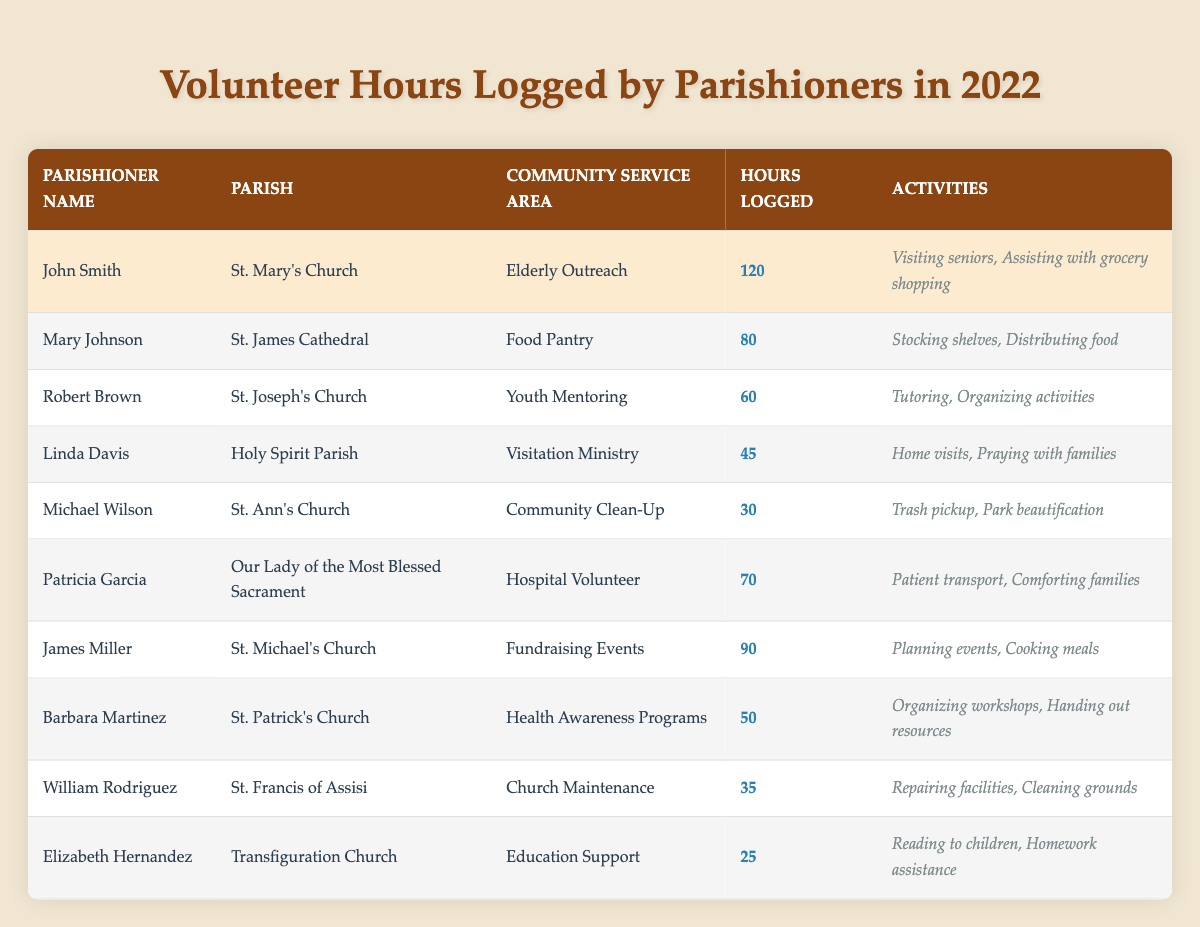What is the total number of volunteer hours logged by all parishioners? To find the total, add the hours logged by each parishioner: 120 + 80 + 60 + 45 + 30 + 70 + 90 + 50 + 35 + 25 = 600.
Answer: 600 Who logged the most volunteer hours in 2022? By comparing the hours logged by each parishioner, John Smith logged the highest at 120 hours.
Answer: John Smith What community service area did Patricia Garcia serve in? The table indicates that Patricia Garcia served in the Hospital Volunteer community service area.
Answer: Hospital Volunteer How many hours did Robert Brown log compared to Linda Davis? Robert Brown logged 60 hours while Linda Davis logged 45 hours. The difference is 60 - 45 = 15.
Answer: 15 hours What activity was done by volunteers in both the Elderly Outreach and Hospital Volunteer community service areas? Both John Smith (Elderly Outreach) and Patricia Garcia (Hospital Volunteer) engaged in activities that focused on assisting and comforting seniors.
Answer: Visiting seniors, comforting families Is the number of hours logged by James Miller more than that of Elizabeth Hernandez? James Miller logged 90 hours, while Elizabeth Hernandez logged 25 hours. Since 90 > 25, the statement is true.
Answer: Yes What is the average number of hours logged by the parishioners? To calculate the average, sum the hours (600) and divide by the number of parishioners (10): 600 / 10 = 60.
Answer: 60 Did any parishioner log fewer than 30 hours? By reviewing the table, the lowest logged hours is 25 by Elizabeth Hernandez, so yes, there is a parishioner who logged fewer than 30 hours.
Answer: Yes How many parishioners logged over 70 hours? The parishioners who logged over 70 hours are John Smith, Mary Johnson, James Miller, and Patricia Garcia. This totals to 4 parishioners.
Answer: 4 Which parish has the most volunteers logged in total? Summing the hours for each parish: St. Mary's Church (120), St. James Cathedral (80), St. Joseph's Church (60), Holy Spirit Parish (45), St. Ann's Church (30), Our Lady of the Most Blessed Sacrament (70), St. Michael's Church (90), St. Patrick's Church (50), St. Francis of Assisi (35), Transfiguration Church (25). St. Mary's Church logged the highest.
Answer: St. Mary's Church 